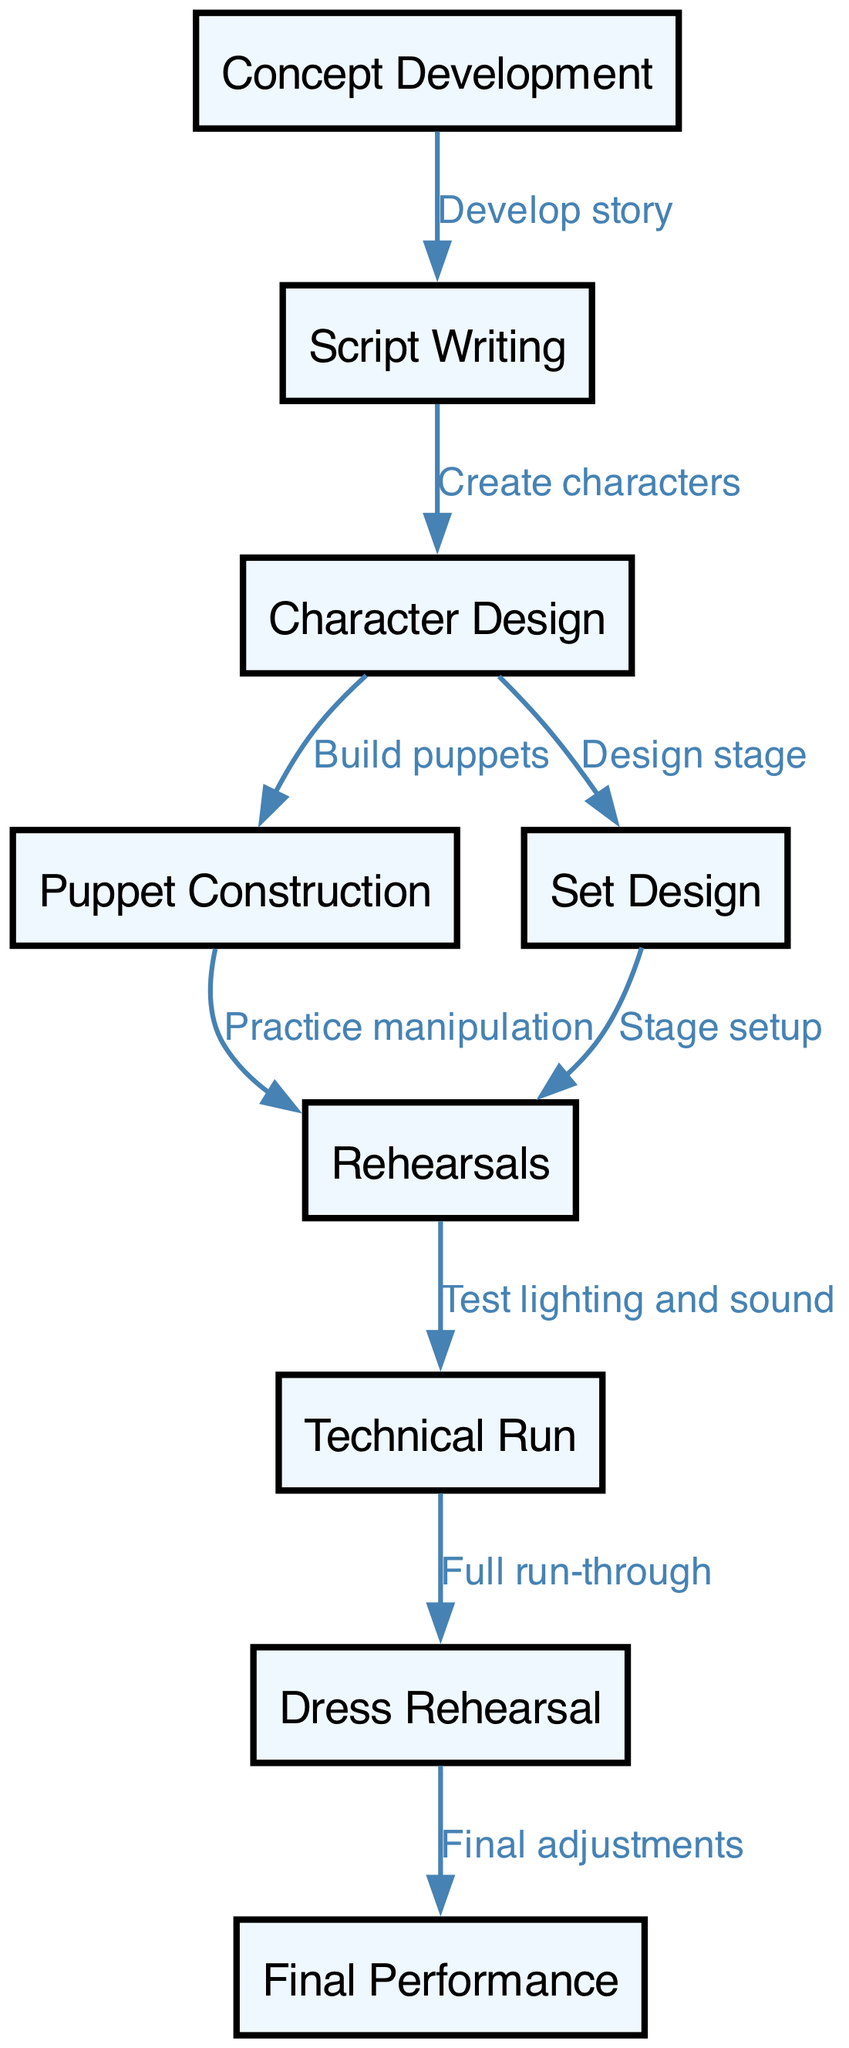What is the first step in the puppetry production workflow? The first step is represented by the node labeled "Concept Development". It is the starting point of the entire process and appears at the top of the diagram.
Answer: Concept Development How many nodes are there in the diagram? The total number of nodes can be counted by identifying each unique labeled box in the diagram. Here, there are 9 distinct steps shown in the workflow.
Answer: 9 What is the relationship between "Script Writing" and "Character Design"? The relationship is indicated by a directed edge that connects these two nodes. "Script Writing" leads to "Character Design", demonstrating that script writing precedes character design.
Answer: Create characters What step directly follows "Dress Rehearsal"? To find this, locate the "Dress Rehearsal" node in the diagram and examine the edge that connects it to another node. The next step after "Dress Rehearsal" is "Final Performance".
Answer: Final Performance How many edges are there in total? The edges can be counted as the lines connecting the nodes, each representing a step in the process. In this diagram, there are 8 edges connecting the various steps in the puppetry production workflow.
Answer: 8 What process occurs after "Technical Run"? Looking at the diagram, the node that directly follows "Technical Run" is "Dress Rehearsal". This indicates that once the technical aspects are tested, a full rehearsal takes place.
Answer: Dress Rehearsal Which node is responsible for "Stage setup"? To answer this, look for the node labeled "Set Design", which connects to "Rehearsals". The flow indicates that set design is primarily responsible for stage setup in preparation for rehearsals.
Answer: Set Design What step is required to "Practice manipulation"? The edge leading to "Practice manipulation" originates from the "Puppet Construction" node. This suggests that practicing how to manipulate the puppets is a direct result of their construction.
Answer: Puppet Construction What leads into the "Final Performance"? The step that leads into the "Final Performance" is the "Dress Rehearsal", illustrated by an arrow showing the flow from one to the other. Adjustments are made after dress rehearsal before the final performance begins.
Answer: Dress Rehearsal 